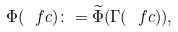Convert formula to latex. <formula><loc_0><loc_0><loc_500><loc_500>\Phi ( \ f c ) \colon = \widetilde { \Phi } ( \Gamma ( \ f c ) ) ,</formula> 